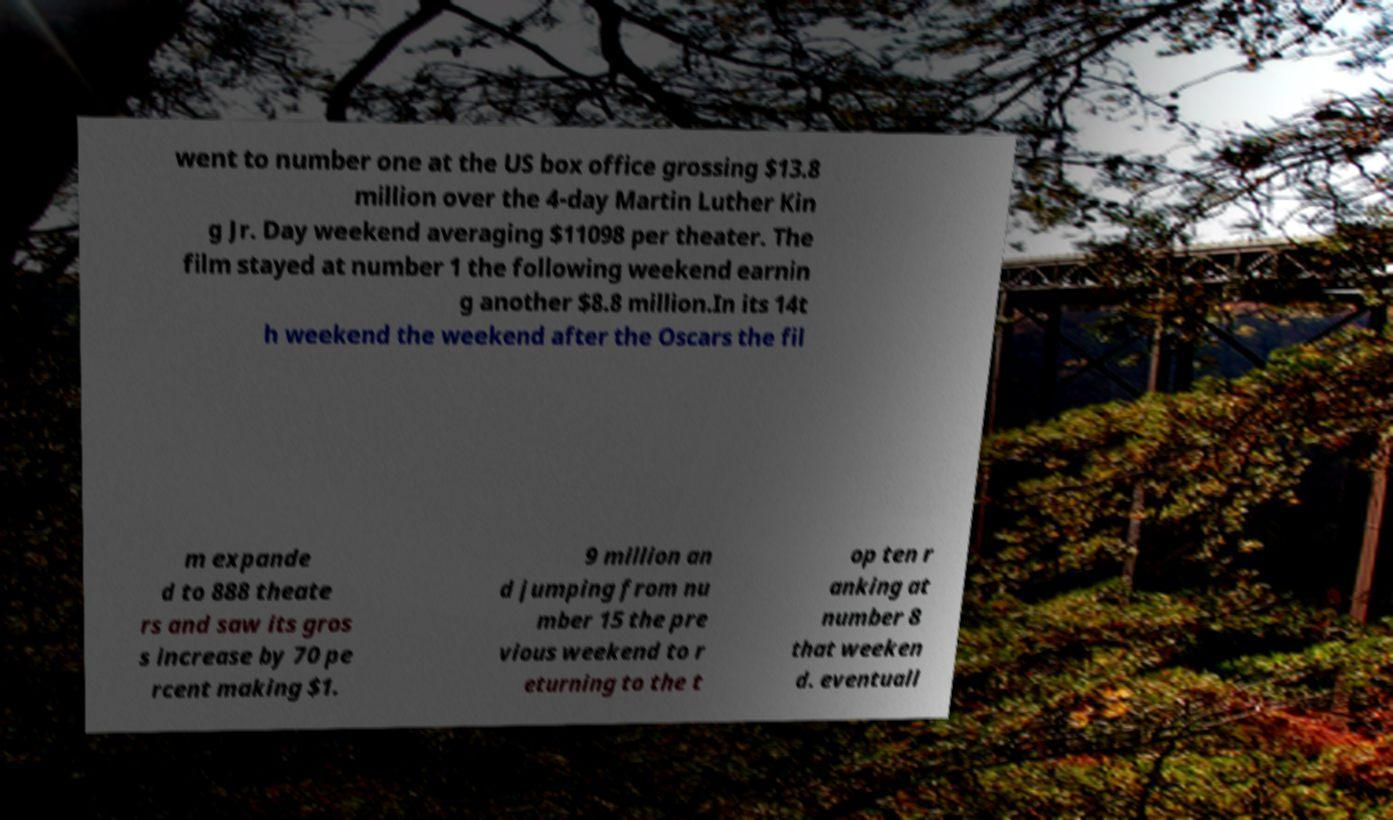Could you extract and type out the text from this image? went to number one at the US box office grossing $13.8 million over the 4-day Martin Luther Kin g Jr. Day weekend averaging $11098 per theater. The film stayed at number 1 the following weekend earnin g another $8.8 million.In its 14t h weekend the weekend after the Oscars the fil m expande d to 888 theate rs and saw its gros s increase by 70 pe rcent making $1. 9 million an d jumping from nu mber 15 the pre vious weekend to r eturning to the t op ten r anking at number 8 that weeken d. eventuall 